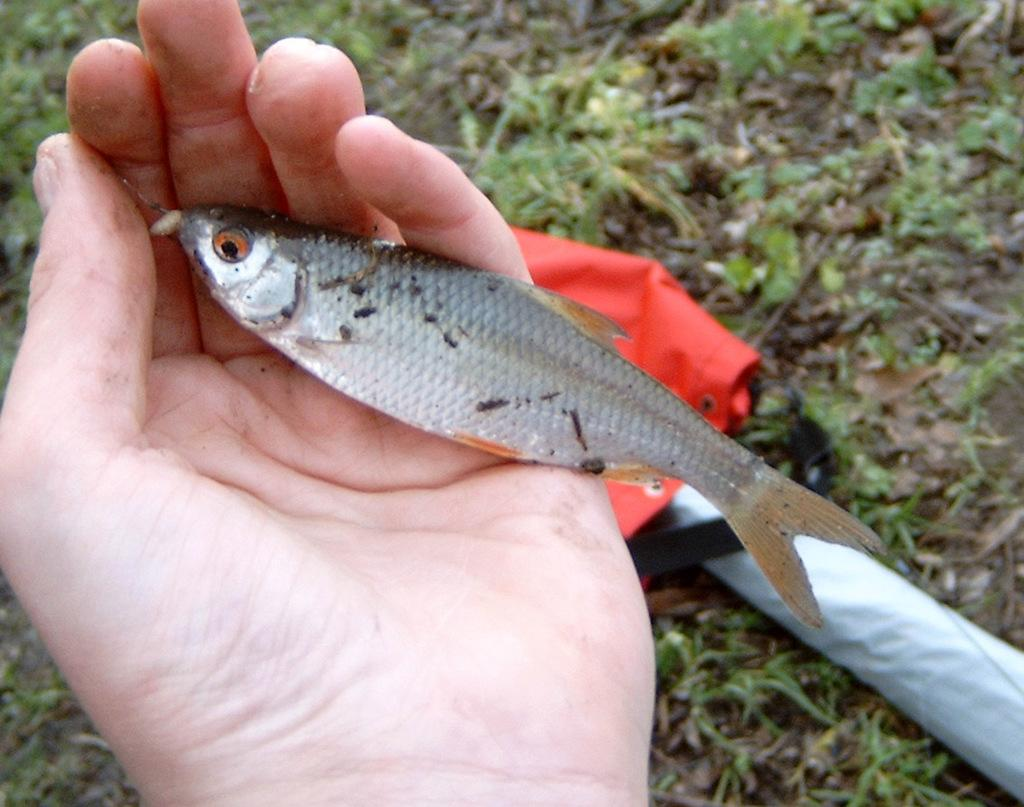Who or what is the main subject in the image? There is a person in the image. What part of the person's body is visible in the image? The person's hand is visible in the image. What is the person holding in their hand? There is a fish in the person's hand. What can be seen in the background of the image? There is a path in the image, and grass is present along the path. What is the appearance of the path? There is a red color cover on the path. What type of trouble is the writer facing in the image? There is no writer or any indication of trouble in the image; it features a person holding a fish on a path with a red cover. 